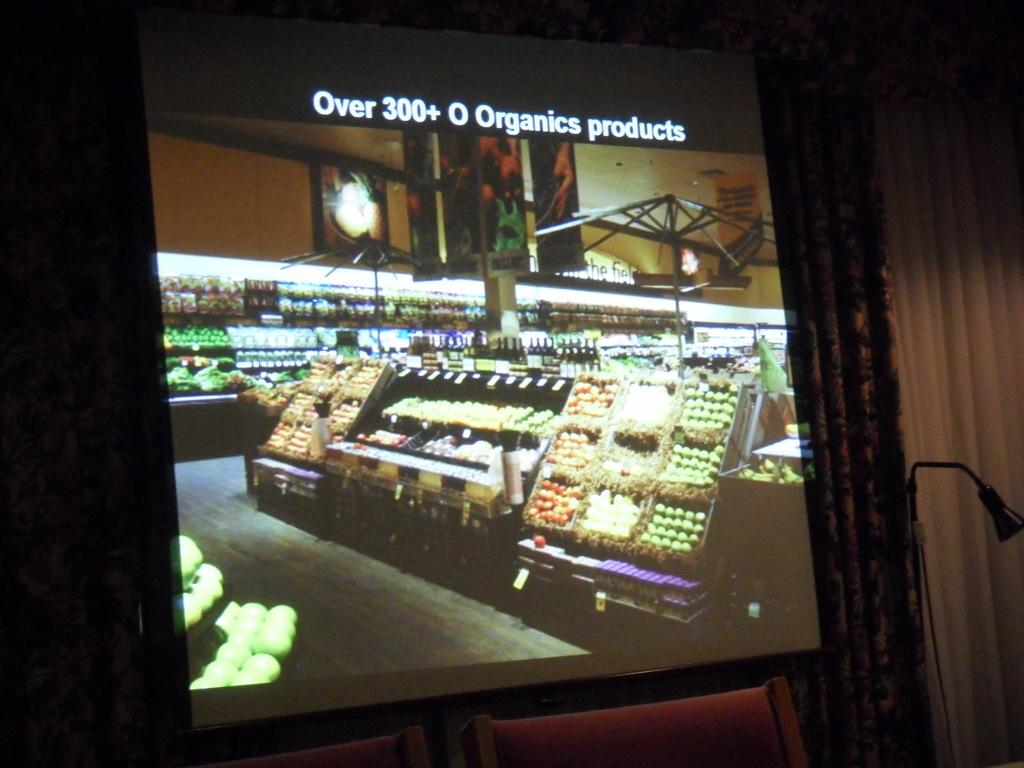<image>
Create a compact narrative representing the image presented. A projection screen shows the interior of a farmers market and boasts over 300 Organic Products 